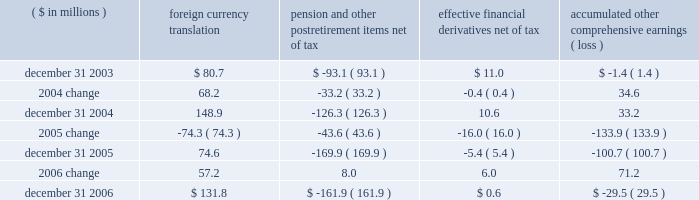Page 73 of 98 notes to consolidated financial statements ball corporation and subsidiaries 15 .
Shareholders 2019 equity at december 31 , 2006 , the company had 550 million shares of common stock and 15 million shares of preferred stock authorized , both without par value .
Preferred stock includes 120000 authorized but unissued shares designated as series a junior participating preferred stock .
Under the company 2019s shareholder rights agreement dated july 26 , 2006 , one preferred stock purchase right ( right ) is attached to each outstanding share of ball corporation common stock .
Subject to adjustment , each right entitles the registered holder to purchase from the company one one-thousandth of a share of series a junior participating preferred stock at an exercise price of $ 185 per right .
If a person or group acquires 10 percent or more of the company 2019s outstanding common stock ( or upon occurrence of certain other events ) , the rights ( other than those held by the acquiring person ) become exercisable and generally entitle the holder to purchase shares of ball corporation common stock at a 50 percent discount .
The rights , which expire in 2016 , are redeemable by the company at a redemption price of $ 0.001 per right and trade with the common stock .
Exercise of such rights would cause substantial dilution to a person or group attempting to acquire control of the company without the approval of ball 2019s board of directors .
The rights would not interfere with any merger or other business combinations approved by the board of directors .
The company reduced its share repurchase program in 2006 to $ 45.7 million , net of issuances , compared to $ 358.1 million net repurchases in 2005 and $ 50 million in 2004 .
The net repurchases in 2006 did not include a forward contract entered into in december 2006 for the repurchase of 1200000 shares .
The contract was settled on january 5 , 2007 , for $ 51.9 million in cash .
In connection with the employee stock purchase plan , the company contributes 20 percent of up to $ 500 of each participating employee 2019s monthly payroll deduction toward the purchase of ball corporation common stock .
Company contributions for this plan were $ 3.2 million in 2006 , $ 3.2 million in 2005 and $ 2.7 million in 2004 .
Accumulated other comprehensive earnings ( loss ) the activity related to accumulated other comprehensive earnings ( loss ) was as follows : ( $ in millions ) foreign currency translation pension and postretirement items , net of tax effective financial derivatives , net of tax accumulated comprehensive earnings ( loss ) .
Notwithstanding the 2005 distribution pursuant to the jobs act , management 2019s intention is to indefinitely reinvest foreign earnings .
Therefore , no taxes have been provided on the foreign currency translation component for any period .
The change in the minimum pension liability is presented net of related tax expense of $ 2.9 million for 2006 and related tax benefits of $ 27.3 million and $ 20.8 million for 2005 and 2004 , respectively .
The change in the effective financial derivatives is presented net of related tax expense of $ 5.7 million for 2006 , related tax benefit of $ 10.7 million for 2005 and related tax benefit of $ 0.2 million for 2004. .
What was the percentage change in accumulated other comprehensive earnings ( loss ) between 2003 and 2004?\\n? 
Computations: (34.6 / 1.4)
Answer: 24.71429. 